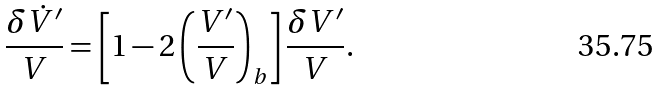Convert formula to latex. <formula><loc_0><loc_0><loc_500><loc_500>\frac { \delta \dot { V } ^ { \prime } } { V } = \left [ 1 - 2 \left ( \frac { V ^ { \prime } } { V } \right ) _ { b } \right ] \frac { \delta V ^ { \prime } } { V } .</formula> 